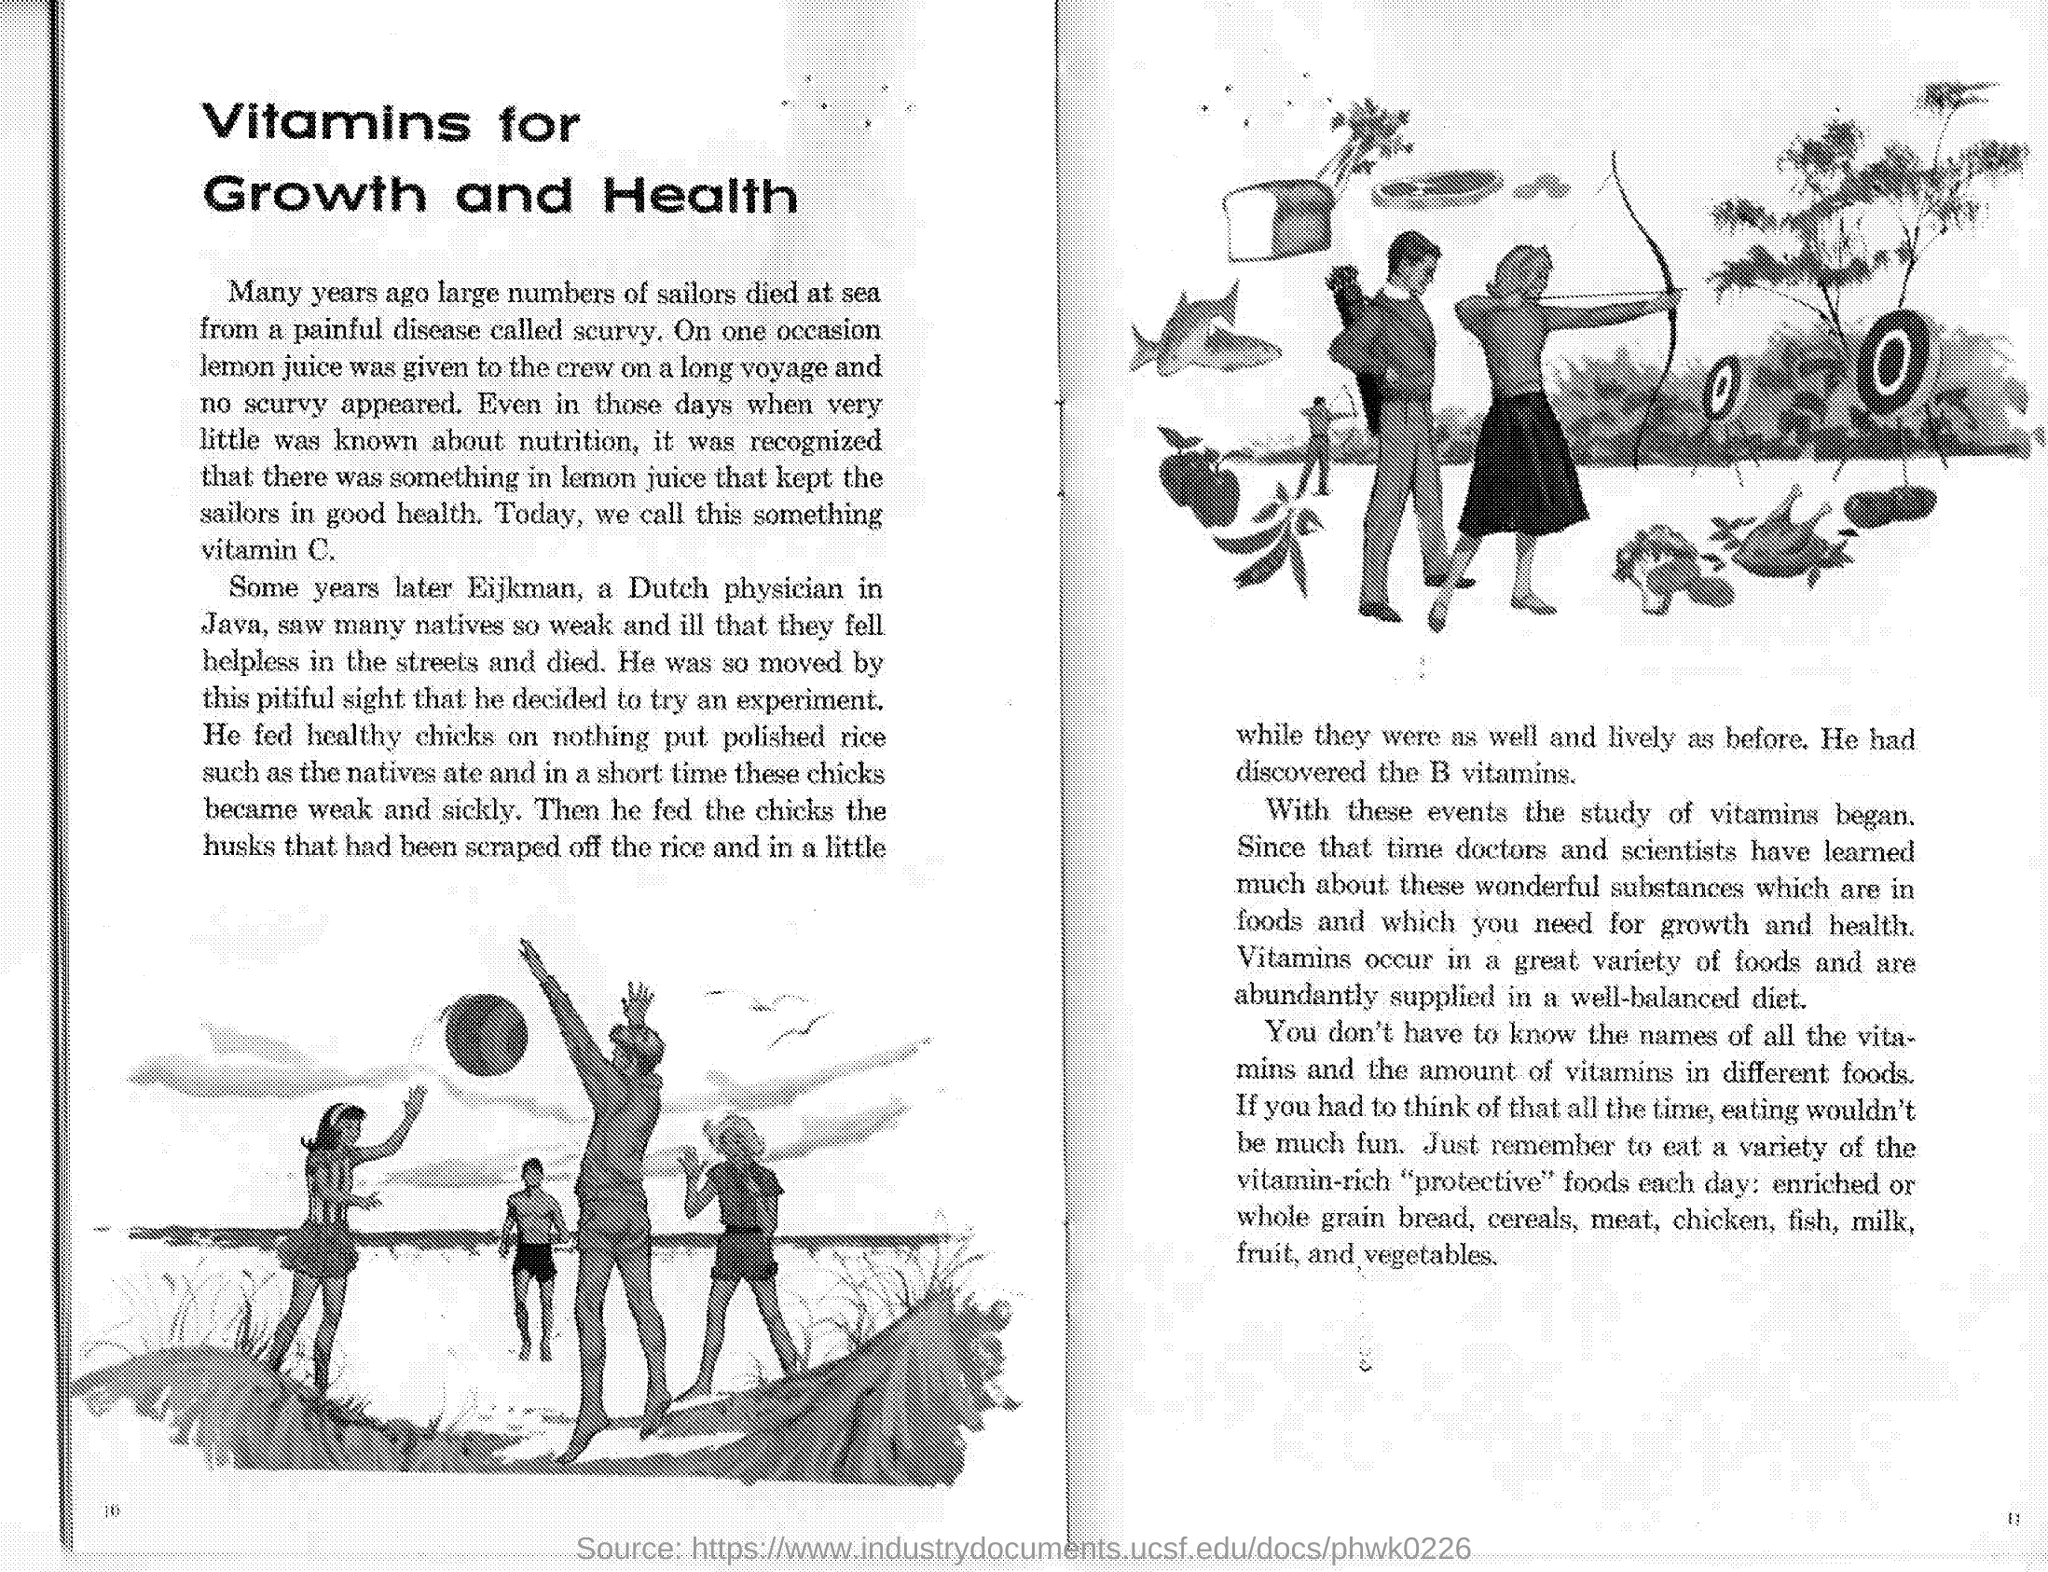Highlight a few significant elements in this photo. Lemon juice is a rich source of vitamin C. In the past, sailors who spent extended periods at sea were prone to contracting a disease known as scurvy. Eijkman discovered vitamin B. The Dutch physician Eijkman conducted experiments on the condition of people in Java. 